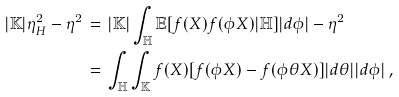Convert formula to latex. <formula><loc_0><loc_0><loc_500><loc_500>| \mathbb { K } | \eta _ { H } ^ { 2 } - \eta ^ { 2 } \, & = \, | \mathbb { K } | \int _ { \mathbb { H } } \mathbb { E } [ f ( X ) f ( \phi X ) | \mathbb { H } ] | d \phi | - \eta ^ { 2 } \\ \, & = \, \int _ { \mathbb { H } } \int _ { \mathbb { K } } f ( X ) [ f ( \phi X ) - f ( \phi \theta X ) ] | d \theta | | d \phi | \, ,</formula> 